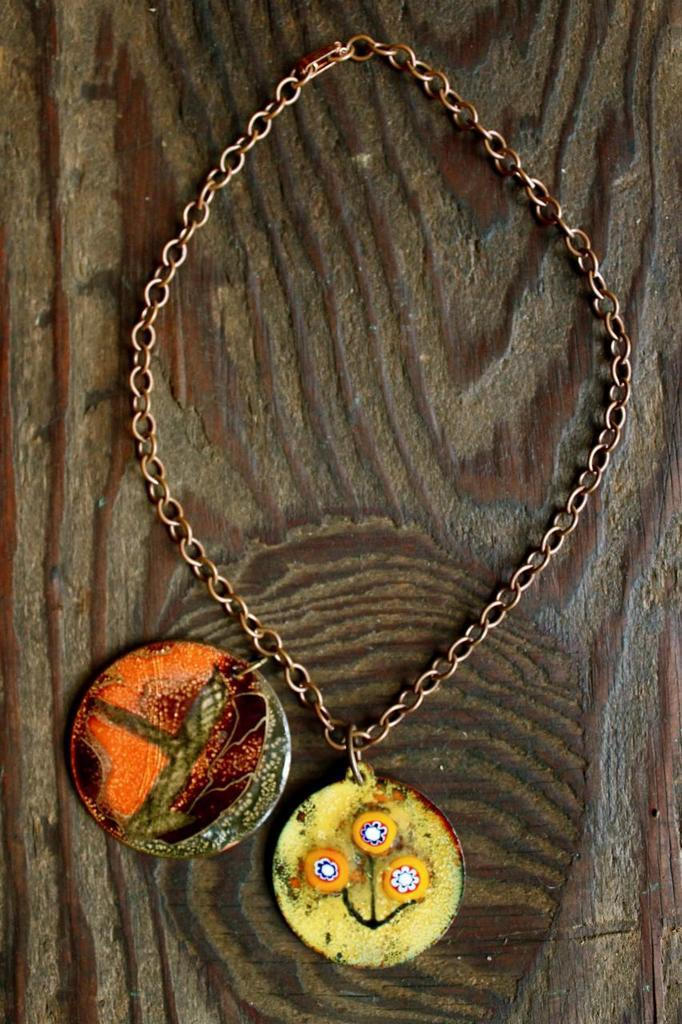What is the main object in the image? There is a chain in the image. What else can be seen attached to the chain? There are two lockets in the image. On what type of surface are the lockets placed? The lockets are placed on a wooden surface. What type of business is being conducted in the image? There is no indication of a business or any activity being conducted in the image. 